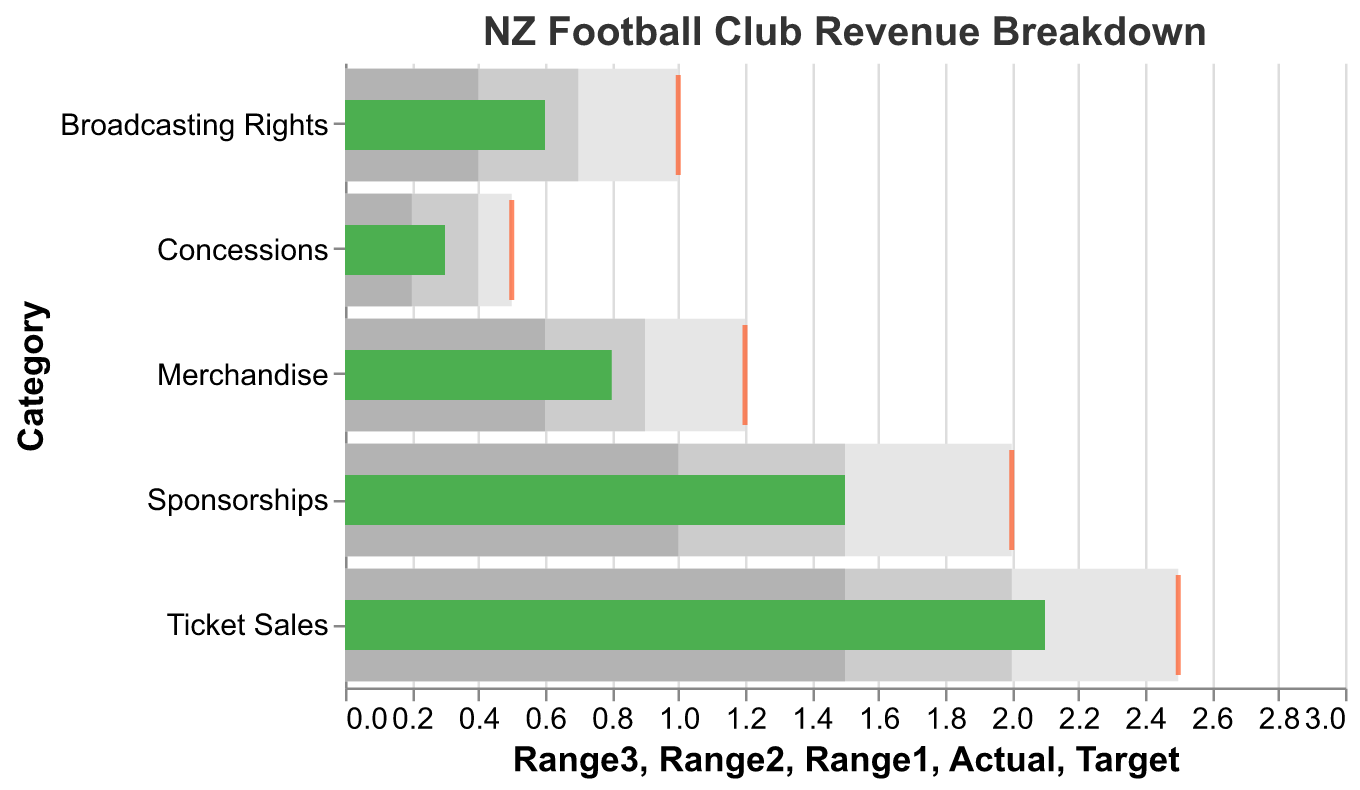How much revenue was generated from ticket sales compared to the target? The "Actual" revenue from ticket sales is 2.1 while the "Target" revenue is 2.5.
Answer: 2.1 compared to 2.5 Which revenue source met its target amount? By comparing the "Actual" and "Target" values for each category, none of the actual revenues met their respective targets.
Answer: None What is the total actual revenue generated across all categories? Sum the actual revenues: 2.1 (Ticket Sales) + 0.8 (Merchandise) + 1.5 (Sponsorships) + 0.6 (Broadcasting Rights) + 0.3 (Concessions).
Answer: 5.3 Which category has the largest gap between actual revenue and target revenue? Calculate the differences: (2.5-2.1)=0.4 for Ticket Sales, (1.2-0.8)=0.4 for Merchandise, (2.0-1.5)=0.5 for Sponsorships, (1.0-0.6)=0.4 for Broadcasting Rights, and (0.5-0.3)=0.2 for Concessions. Sponsorships has the largest gap of 0.5.
Answer: Sponsorships What is the median value of the target revenues across all categories? First, list all target revenues: 2.5, 1.2, 2.0, 1.0, 0.5. When these values are ordered (0.5, 1.0, 1.2, 2.0, 2.5), the median value is the middle one, which is 1.2.
Answer: 1.2 What percentage of the target revenue was achieved by merchandise? The actual revenue for merchandise is 0.8 and the target is 1.2. The percentage is calculated as (0.8 / 1.2) * 100.
Answer: ~66.67% Which category exceeded the lower range but did not meet the upper range of their target? Compare each "Actual" value against "Range1" and "Range3" respectively: Ticket Sales (2.1 exceeds 1.5 but meets 2.5), Merchandise (0.8 exceeds 0.6 but meets 1.2), Sponsorships (1.5 exceeds 1.0 but meets 2.0), Broadcasting Rights (0.6 exceeds 0.4 but meets 1.0), Concessions (0.3 exceeds 0.2 but meets 0.5). All categories fall into this criteria.
Answer: All categories 